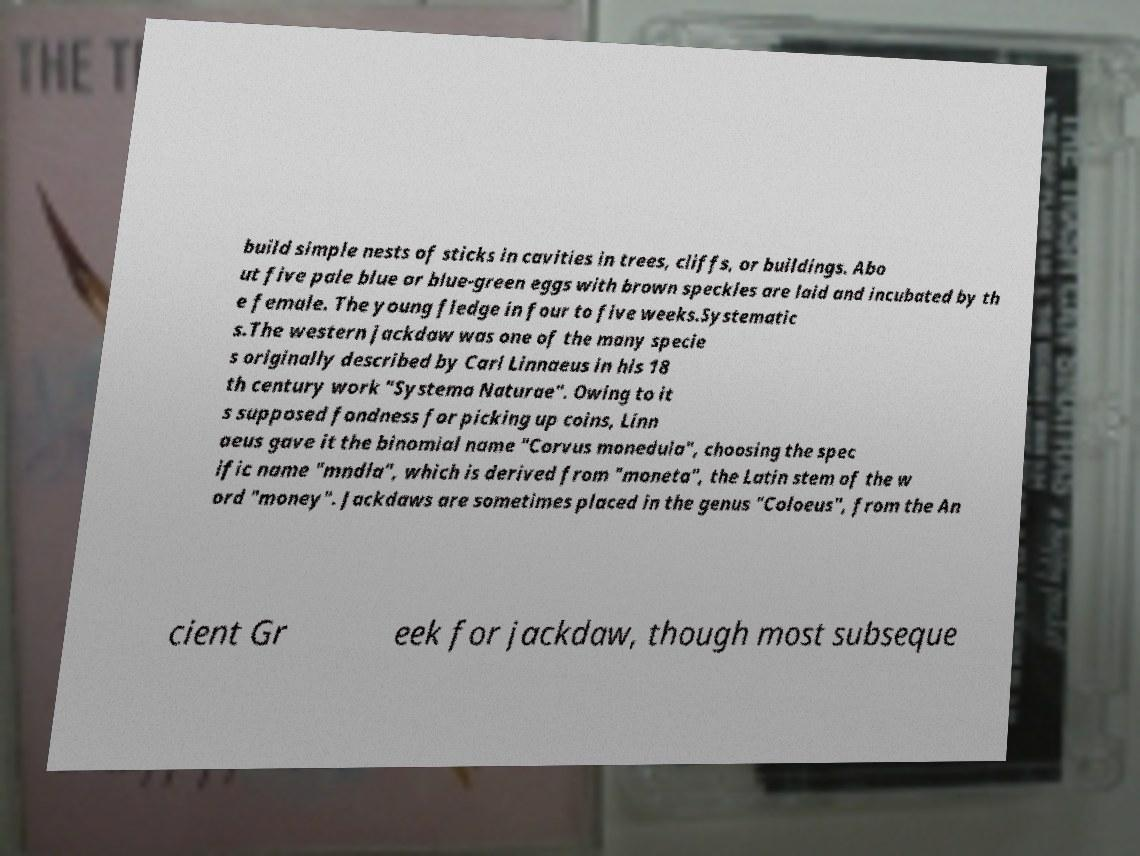Please read and relay the text visible in this image. What does it say? build simple nests of sticks in cavities in trees, cliffs, or buildings. Abo ut five pale blue or blue-green eggs with brown speckles are laid and incubated by th e female. The young fledge in four to five weeks.Systematic s.The western jackdaw was one of the many specie s originally described by Carl Linnaeus in his 18 th century work "Systema Naturae". Owing to it s supposed fondness for picking up coins, Linn aeus gave it the binomial name "Corvus monedula", choosing the spec ific name "mndla", which is derived from "moneta", the Latin stem of the w ord "money". Jackdaws are sometimes placed in the genus "Coloeus", from the An cient Gr eek for jackdaw, though most subseque 